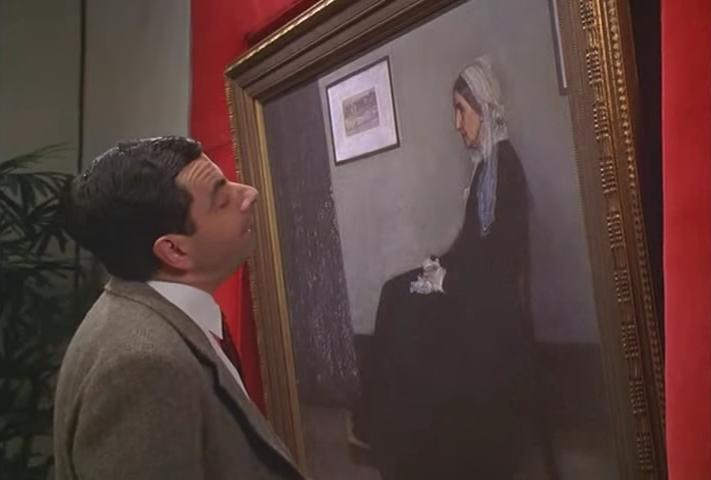Can you describe the main features of this image for me? In this image, we see the renowned actor Rowan Atkinson, famously known for his character Mr. Bean, standing in front of a large painting. Dressed in a dark suit and tie, Mr. Bean is positioned slightly to the left of the frame, looking up at the painting with a curious expression on his face. The painting, encased in a gold frame, is hung on a red wall and depicts a woman in a blue dress with a white headscarf, holding a teapot. The contrast between Mr. Bean's comedic persona and the solemnity of the painting creates an interesting dynamic in the scene. 